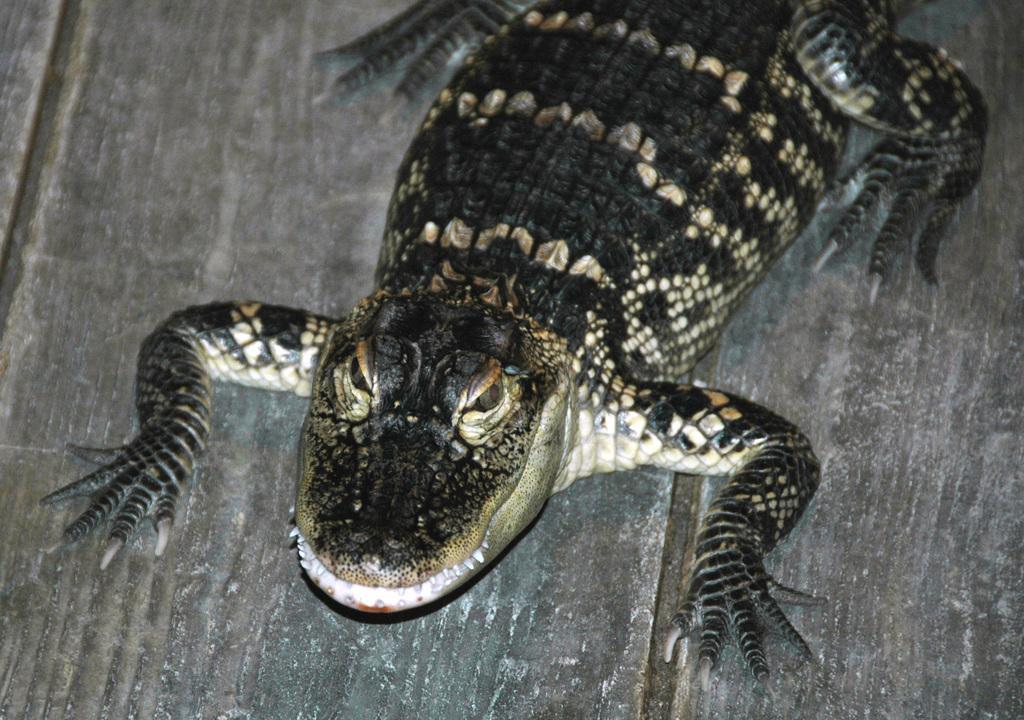Describe this image in one or two sentences. In the picture I can see an animal on the wooden surface. 